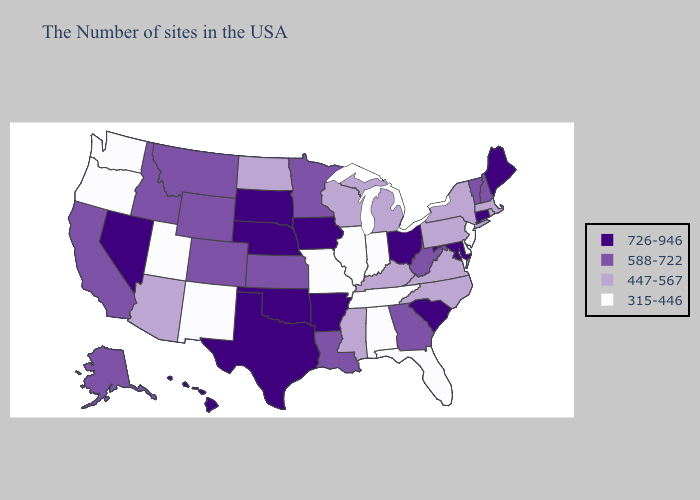Among the states that border California , does Oregon have the lowest value?
Be succinct. Yes. Does Georgia have the lowest value in the South?
Concise answer only. No. Name the states that have a value in the range 726-946?
Keep it brief. Maine, Connecticut, Maryland, South Carolina, Ohio, Arkansas, Iowa, Nebraska, Oklahoma, Texas, South Dakota, Nevada, Hawaii. Name the states that have a value in the range 315-446?
Write a very short answer. New Jersey, Delaware, Florida, Indiana, Alabama, Tennessee, Illinois, Missouri, New Mexico, Utah, Washington, Oregon. What is the value of Alabama?
Be succinct. 315-446. What is the value of South Carolina?
Keep it brief. 726-946. Among the states that border South Carolina , does Georgia have the lowest value?
Answer briefly. No. Does New Mexico have the lowest value in the West?
Be succinct. Yes. Name the states that have a value in the range 447-567?
Be succinct. Massachusetts, Rhode Island, New York, Pennsylvania, Virginia, North Carolina, Michigan, Kentucky, Wisconsin, Mississippi, North Dakota, Arizona. What is the value of South Carolina?
Quick response, please. 726-946. Among the states that border Idaho , which have the highest value?
Write a very short answer. Nevada. Name the states that have a value in the range 447-567?
Write a very short answer. Massachusetts, Rhode Island, New York, Pennsylvania, Virginia, North Carolina, Michigan, Kentucky, Wisconsin, Mississippi, North Dakota, Arizona. What is the lowest value in states that border Wyoming?
Answer briefly. 315-446. Which states have the lowest value in the MidWest?
Write a very short answer. Indiana, Illinois, Missouri. Does Washington have the lowest value in the West?
Write a very short answer. Yes. 